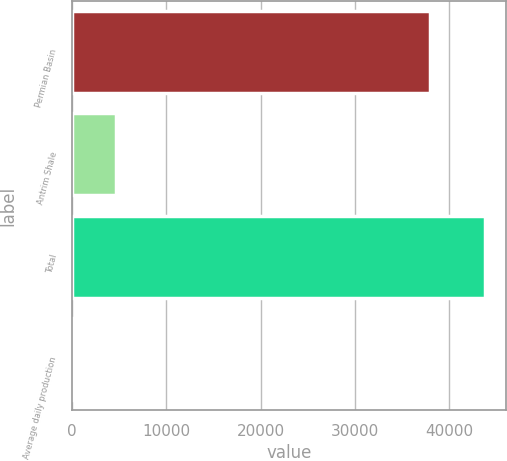Convert chart to OTSL. <chart><loc_0><loc_0><loc_500><loc_500><bar_chart><fcel>Permian Basin<fcel>Antrim Shale<fcel>Total<fcel>Average daily production<nl><fcel>37938<fcel>4634.3<fcel>43769<fcel>286<nl></chart> 